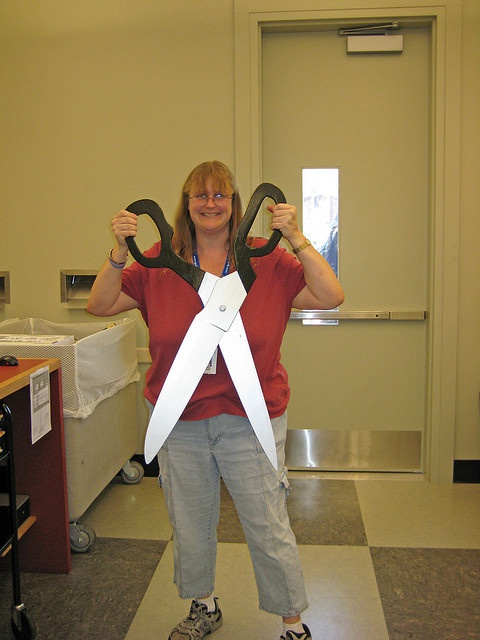Describe the objects in this image and their specific colors. I can see people in olive, gray, tan, white, and brown tones and scissors in olive, white, black, tan, and gray tones in this image. 